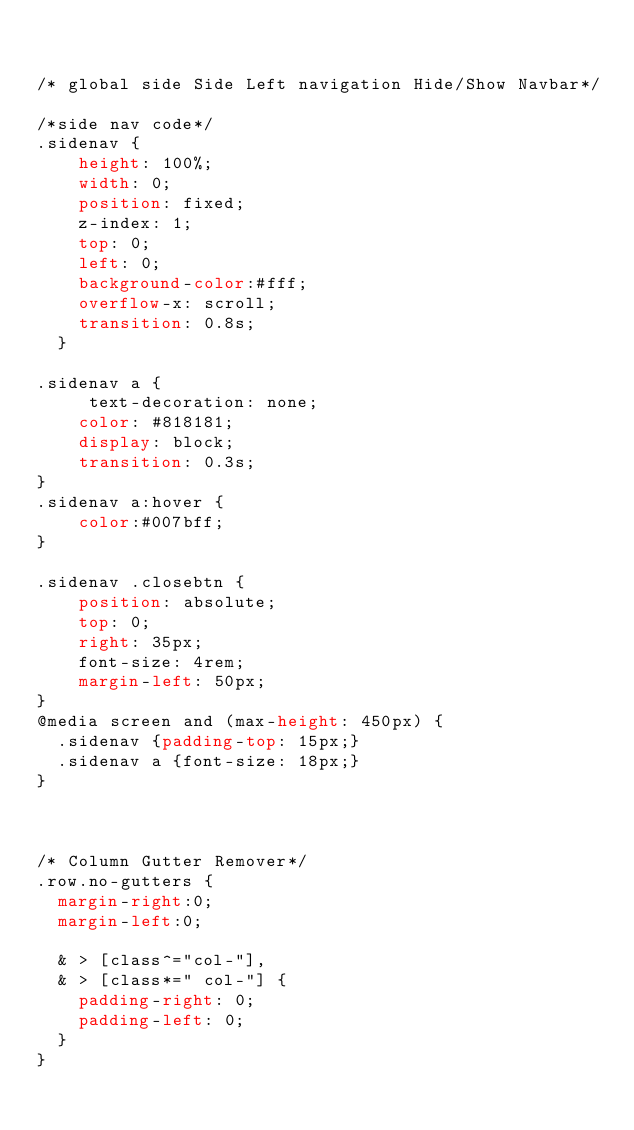Convert code to text. <code><loc_0><loc_0><loc_500><loc_500><_CSS_>
 
/* global side Side Left navigation Hide/Show Navbar*/	
/*side nav code*/	
.sidenav {
    height: 100%;
    width: 0;
    position: fixed;
    z-index: 1;
    top: 0;
    left: 0;
    background-color:#fff;
    overflow-x: scroll;
    transition: 0.8s;
  }

.sidenav a {
     text-decoration: none;
    color: #818181;
    display: block;
    transition: 0.3s;
}
.sidenav a:hover {
    color:#007bff;
}

.sidenav .closebtn {
    position: absolute;
    top: 0;
    right: 35px;
    font-size: 4rem;
    margin-left: 50px;
}
@media screen and (max-height: 450px) {
  .sidenav {padding-top: 15px;}
  .sidenav a {font-size: 18px;}
}



/* Column Gutter Remover*/	
.row.no-gutters {
  margin-right:0;
  margin-left:0;

  & > [class^="col-"],
  & > [class*=" col-"] {
    padding-right: 0;
    padding-left: 0;
  }
}
 </code> 